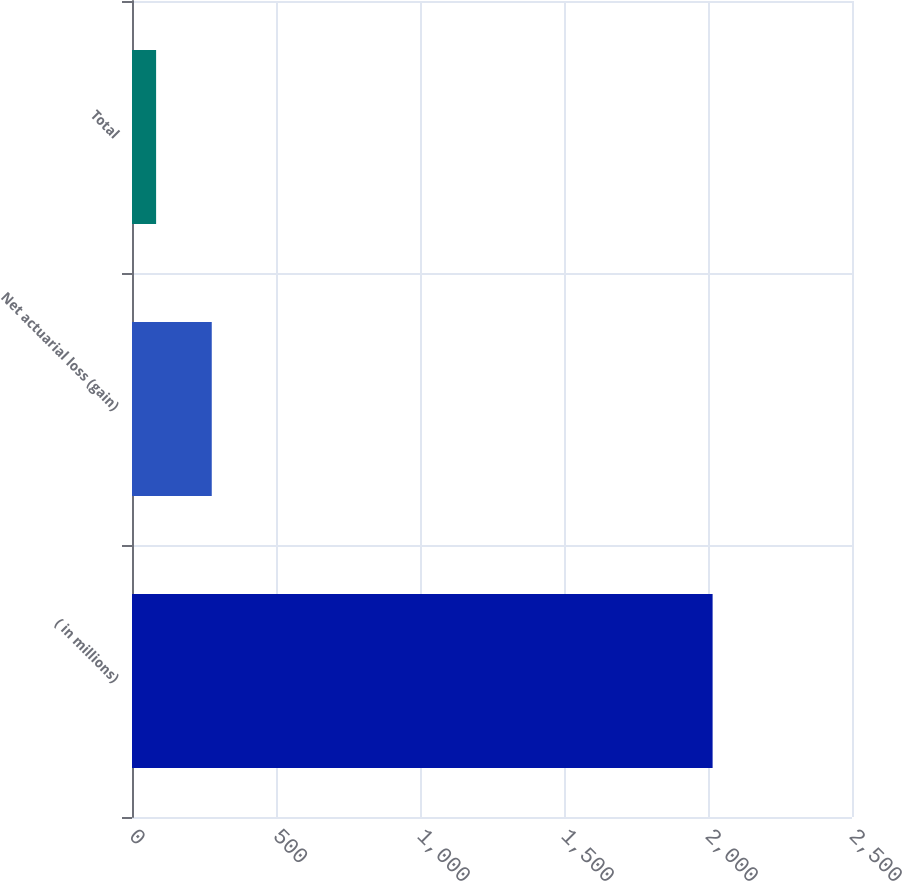Convert chart to OTSL. <chart><loc_0><loc_0><loc_500><loc_500><bar_chart><fcel>( in millions)<fcel>Net actuarial loss (gain)<fcel>Total<nl><fcel>2016<fcel>276.93<fcel>83.7<nl></chart> 